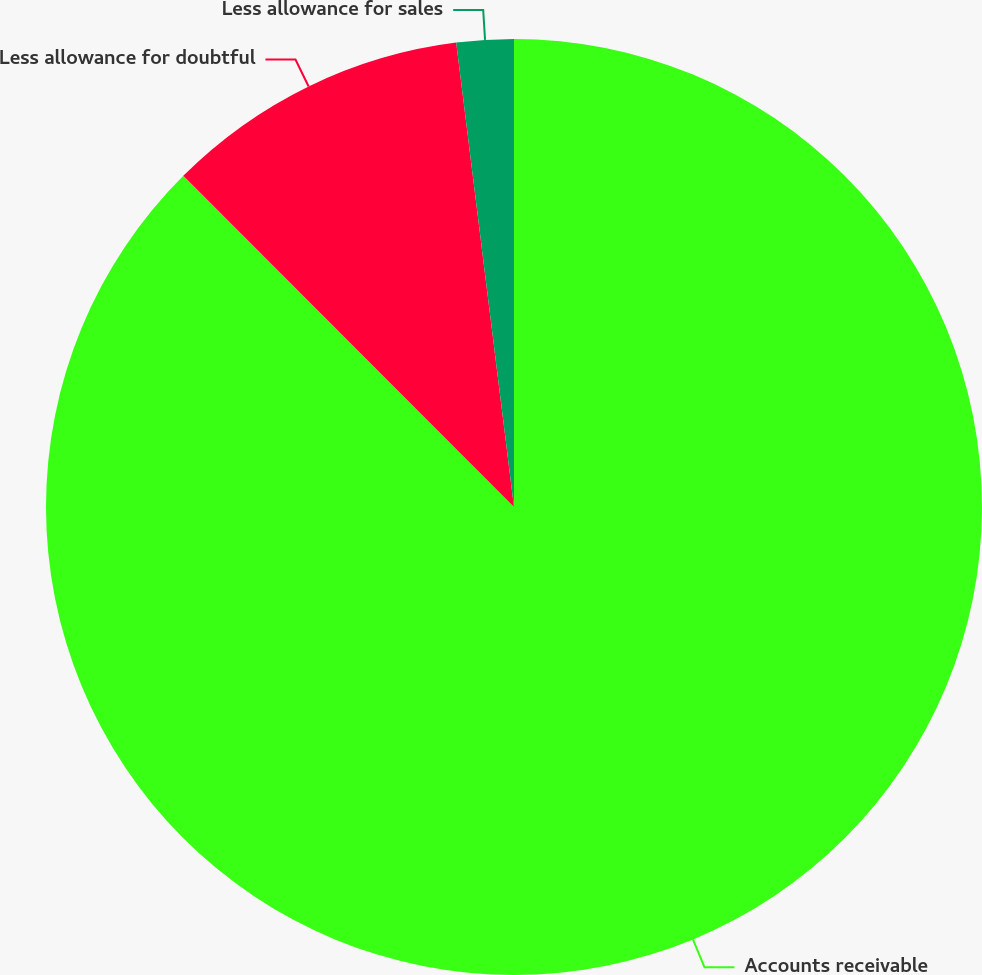<chart> <loc_0><loc_0><loc_500><loc_500><pie_chart><fcel>Accounts receivable<fcel>Less allowance for doubtful<fcel>Less allowance for sales<nl><fcel>87.51%<fcel>10.52%<fcel>1.97%<nl></chart> 